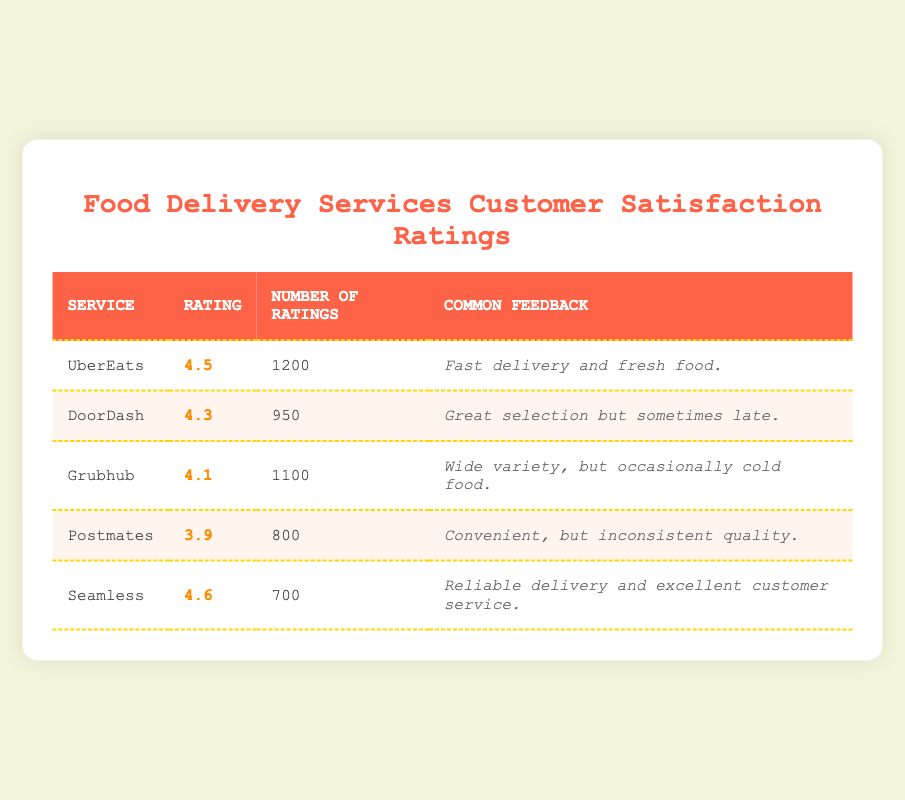What is the highest customer satisfaction rating among the food delivery services? The table shows ratings for each service, with Seamless having the highest rating at 4.6.
Answer: 4.6 How many total ratings were given for DoorDash? According to the table, DoorDash has a total of 950 ratings recorded.
Answer: 950 Is the customer feedback for Grubhub more positive than that for Postmates? Grubhub has feedback indicating a wide variety but notes occasional cold food, while Postmates mentions convenient service but inconsistent quality. This indicates that Grubhub has a more positive aspect overall.
Answer: Yes What is the average rating of all the food delivery services listed? To find the average, sum the ratings: (4.5 + 4.3 + 4.1 + 3.9 + 4.6) = 21.4, and there are 5 services, so the average is 21.4 / 5 = 4.28.
Answer: 4.28 How many ratings did Seamless receive? The table shows that Seamless received a total of 700 ratings.
Answer: 700 Which service has the lowest rating and what is that rating? Postmates has the lowest rating listed in the table at 3.9.
Answer: Postmates, 3.9 Is it true that the ratings for UberEats are higher than those for Grubhub? Yes, UberEats has a rating of 4.5, which is higher than Grubhub's rating of 4.1.
Answer: Yes What is the difference in the number of ratings between Grubhub and Postmates? Grubhub has 1100 ratings and Postmates has 800 ratings. The difference is 1100 - 800 = 300 ratings.
Answer: 300 